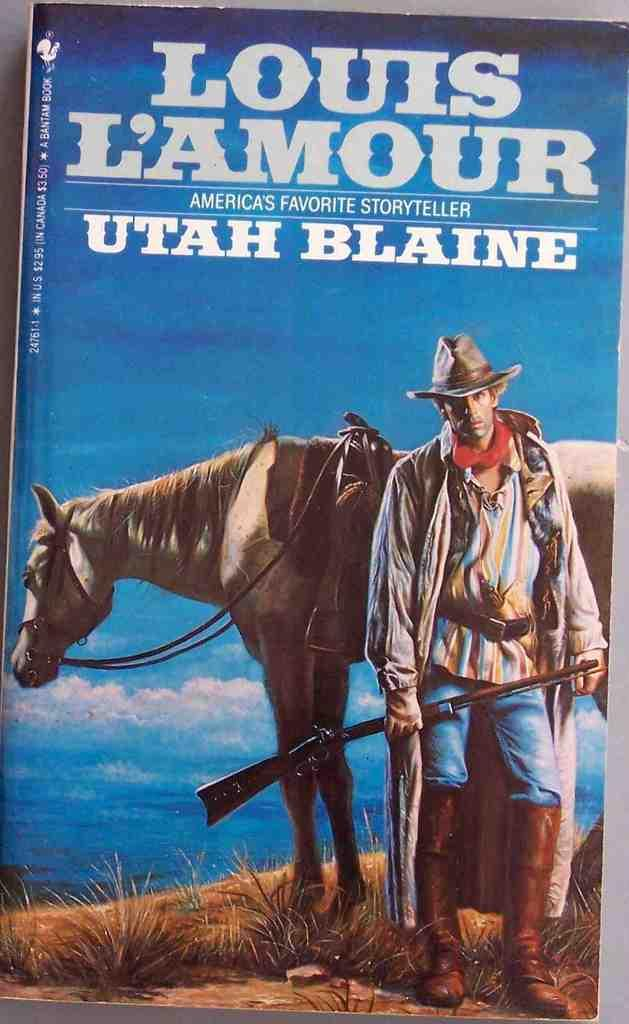What is the main subject of the image? The main subject of the image is a man. What is the man doing in the image? The man is standing in the image. What is the man wearing in the image? The man is wearing clothes, boots, and a hat in the image. What is the man holding in the image? The man is holding a rifle in his hands in the image. What other living creature is present in the image? There is a horse in the image. What type of natural environment is visible in the image? There is grass in the image, which suggests a natural environment. What is visible in the background of the image? The sky is visible in the image. Is there any text present in the image? Yes, there is text in the image. What value does the committee assign to the observation made by the man in the image? There is no committee or observation mentioned in the image, so it is not possible to determine the value assigned by a committee. 